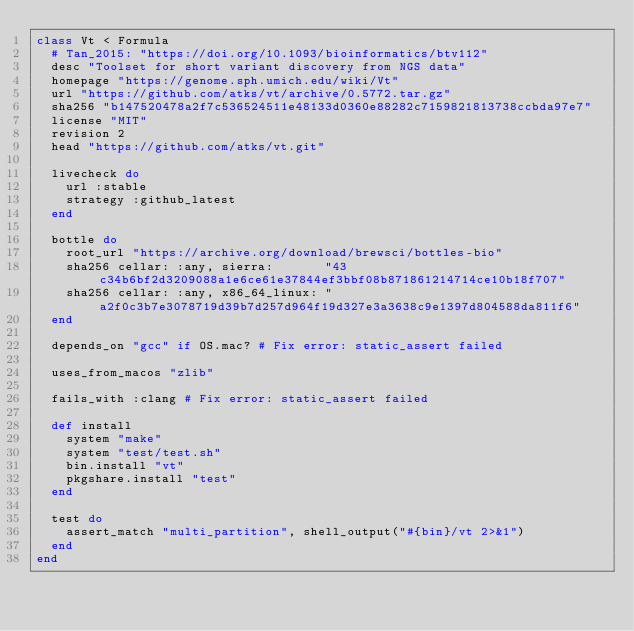Convert code to text. <code><loc_0><loc_0><loc_500><loc_500><_Ruby_>class Vt < Formula
  # Tan_2015: "https://doi.org/10.1093/bioinformatics/btv112"
  desc "Toolset for short variant discovery from NGS data"
  homepage "https://genome.sph.umich.edu/wiki/Vt"
  url "https://github.com/atks/vt/archive/0.5772.tar.gz"
  sha256 "b147520478a2f7c536524511e48133d0360e88282c7159821813738ccbda97e7"
  license "MIT"
  revision 2
  head "https://github.com/atks/vt.git"

  livecheck do
    url :stable
    strategy :github_latest
  end

  bottle do
    root_url "https://archive.org/download/brewsci/bottles-bio"
    sha256 cellar: :any, sierra:       "43c34b6bf2d3209088a1e6ce61e37844ef3bbf08b871861214714ce10b18f707"
    sha256 cellar: :any, x86_64_linux: "a2f0c3b7e3078719d39b7d257d964f19d327e3a3638c9e1397d804588da811f6"
  end

  depends_on "gcc" if OS.mac? # Fix error: static_assert failed

  uses_from_macos "zlib"

  fails_with :clang # Fix error: static_assert failed

  def install
    system "make"
    system "test/test.sh"
    bin.install "vt"
    pkgshare.install "test"
  end

  test do
    assert_match "multi_partition", shell_output("#{bin}/vt 2>&1")
  end
end
</code> 